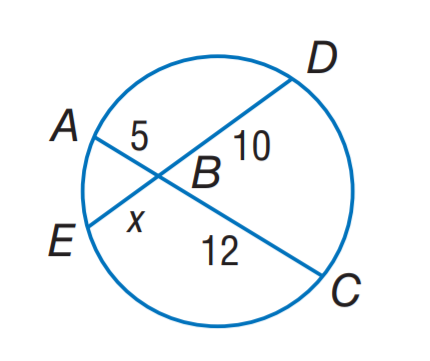Question: Find x.
Choices:
A. 5
B. 6
C. 10
D. 12
Answer with the letter. Answer: B 